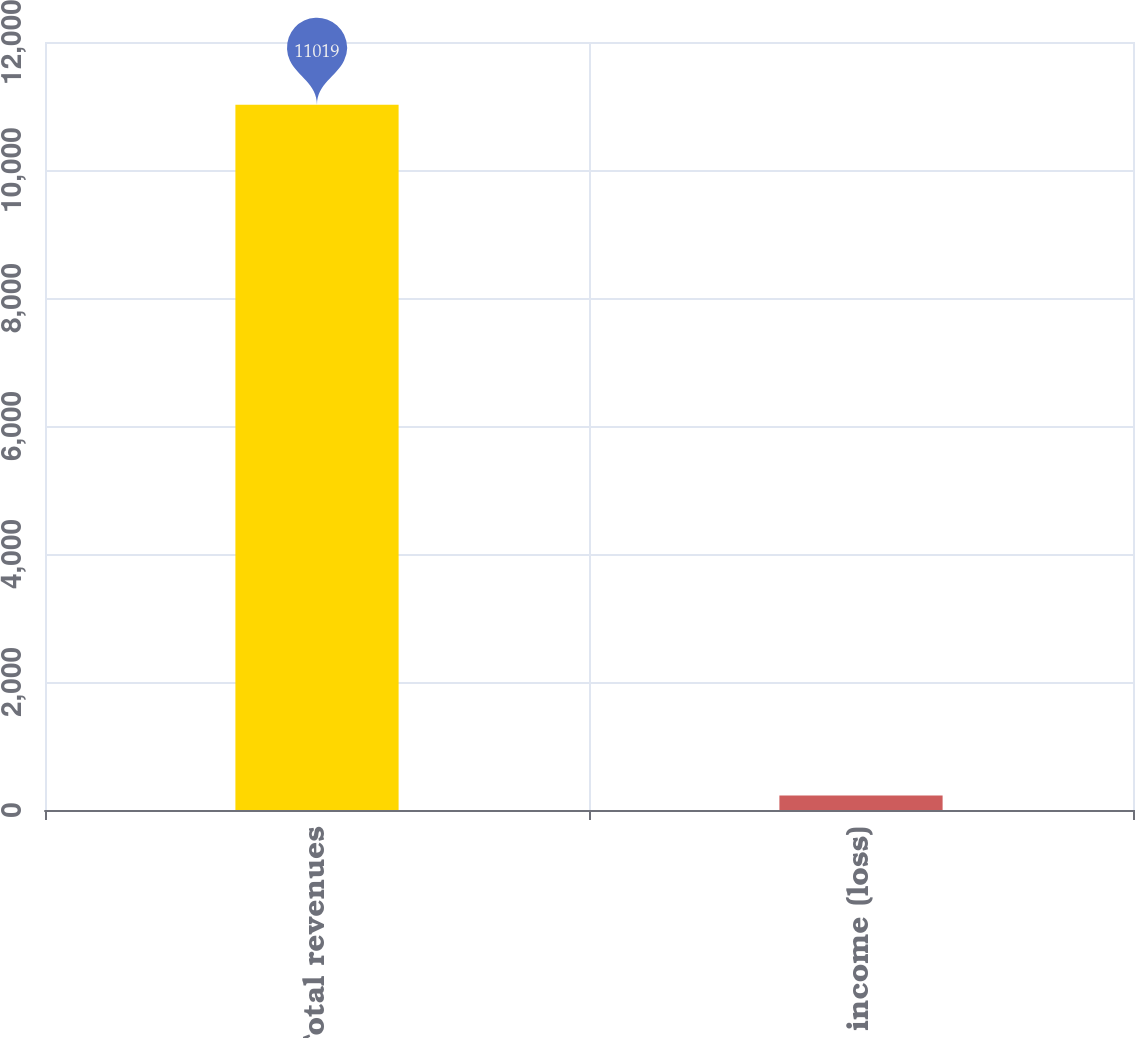<chart> <loc_0><loc_0><loc_500><loc_500><bar_chart><fcel>Total revenues<fcel>Net income (loss)<nl><fcel>11019<fcel>227<nl></chart> 